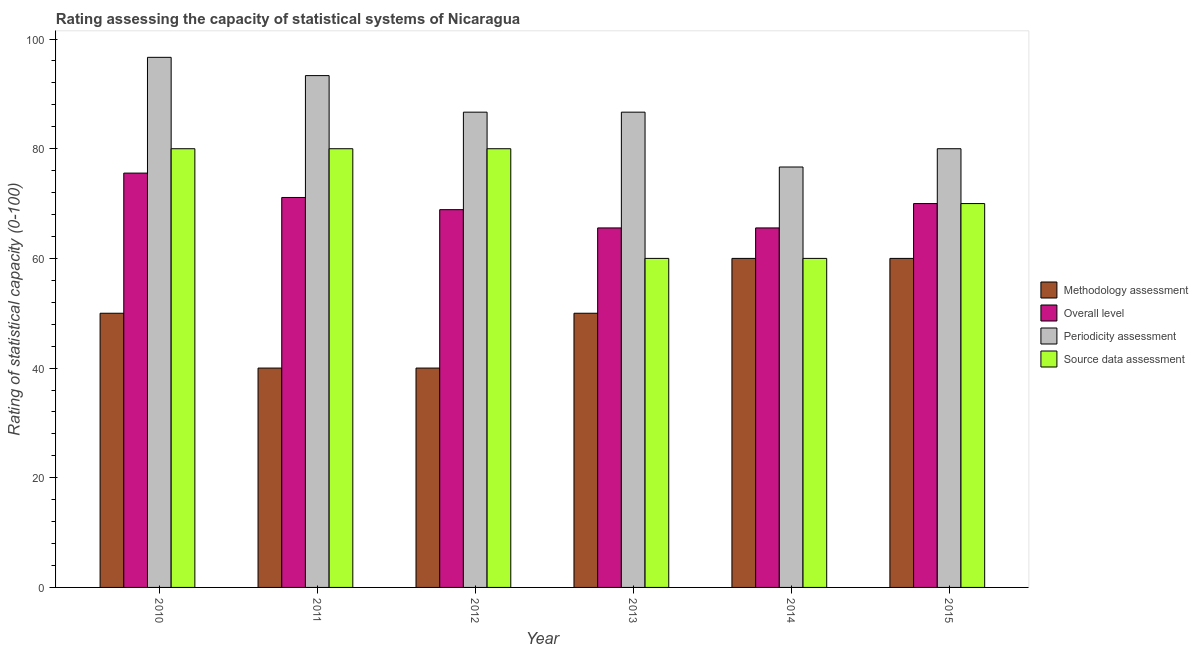Are the number of bars per tick equal to the number of legend labels?
Offer a very short reply. Yes. What is the label of the 4th group of bars from the left?
Provide a succinct answer. 2013. What is the methodology assessment rating in 2011?
Ensure brevity in your answer.  40. Across all years, what is the maximum source data assessment rating?
Provide a short and direct response. 80. Across all years, what is the minimum methodology assessment rating?
Provide a short and direct response. 40. In which year was the methodology assessment rating maximum?
Your response must be concise. 2014. In which year was the source data assessment rating minimum?
Provide a short and direct response. 2013. What is the total periodicity assessment rating in the graph?
Give a very brief answer. 520. What is the difference between the periodicity assessment rating in 2014 and that in 2015?
Provide a short and direct response. -3.33. What is the difference between the overall level rating in 2013 and the methodology assessment rating in 2011?
Your response must be concise. -5.56. What is the ratio of the periodicity assessment rating in 2010 to that in 2013?
Keep it short and to the point. 1.12. Is the overall level rating in 2010 less than that in 2015?
Offer a very short reply. No. Is the difference between the methodology assessment rating in 2012 and 2015 greater than the difference between the periodicity assessment rating in 2012 and 2015?
Your answer should be compact. No. What is the difference between the highest and the lowest periodicity assessment rating?
Give a very brief answer. 20. What does the 3rd bar from the left in 2015 represents?
Keep it short and to the point. Periodicity assessment. What does the 4th bar from the right in 2011 represents?
Your answer should be compact. Methodology assessment. Is it the case that in every year, the sum of the methodology assessment rating and overall level rating is greater than the periodicity assessment rating?
Make the answer very short. Yes. How many bars are there?
Make the answer very short. 24. How many years are there in the graph?
Give a very brief answer. 6. What is the difference between two consecutive major ticks on the Y-axis?
Your answer should be compact. 20. Does the graph contain any zero values?
Keep it short and to the point. No. Does the graph contain grids?
Ensure brevity in your answer.  No. How many legend labels are there?
Provide a succinct answer. 4. What is the title of the graph?
Provide a short and direct response. Rating assessing the capacity of statistical systems of Nicaragua. What is the label or title of the Y-axis?
Provide a succinct answer. Rating of statistical capacity (0-100). What is the Rating of statistical capacity (0-100) in Overall level in 2010?
Your answer should be very brief. 75.56. What is the Rating of statistical capacity (0-100) in Periodicity assessment in 2010?
Your answer should be compact. 96.67. What is the Rating of statistical capacity (0-100) of Methodology assessment in 2011?
Provide a succinct answer. 40. What is the Rating of statistical capacity (0-100) of Overall level in 2011?
Your answer should be compact. 71.11. What is the Rating of statistical capacity (0-100) of Periodicity assessment in 2011?
Give a very brief answer. 93.33. What is the Rating of statistical capacity (0-100) of Source data assessment in 2011?
Make the answer very short. 80. What is the Rating of statistical capacity (0-100) in Overall level in 2012?
Provide a succinct answer. 68.89. What is the Rating of statistical capacity (0-100) of Periodicity assessment in 2012?
Keep it short and to the point. 86.67. What is the Rating of statistical capacity (0-100) in Source data assessment in 2012?
Offer a very short reply. 80. What is the Rating of statistical capacity (0-100) of Methodology assessment in 2013?
Your answer should be very brief. 50. What is the Rating of statistical capacity (0-100) of Overall level in 2013?
Give a very brief answer. 65.56. What is the Rating of statistical capacity (0-100) in Periodicity assessment in 2013?
Give a very brief answer. 86.67. What is the Rating of statistical capacity (0-100) of Source data assessment in 2013?
Offer a very short reply. 60. What is the Rating of statistical capacity (0-100) of Overall level in 2014?
Offer a terse response. 65.56. What is the Rating of statistical capacity (0-100) of Periodicity assessment in 2014?
Provide a short and direct response. 76.67. What is the Rating of statistical capacity (0-100) of Periodicity assessment in 2015?
Give a very brief answer. 80. Across all years, what is the maximum Rating of statistical capacity (0-100) in Methodology assessment?
Ensure brevity in your answer.  60. Across all years, what is the maximum Rating of statistical capacity (0-100) in Overall level?
Your response must be concise. 75.56. Across all years, what is the maximum Rating of statistical capacity (0-100) of Periodicity assessment?
Keep it short and to the point. 96.67. Across all years, what is the maximum Rating of statistical capacity (0-100) in Source data assessment?
Offer a terse response. 80. Across all years, what is the minimum Rating of statistical capacity (0-100) in Overall level?
Provide a succinct answer. 65.56. Across all years, what is the minimum Rating of statistical capacity (0-100) in Periodicity assessment?
Offer a very short reply. 76.67. Across all years, what is the minimum Rating of statistical capacity (0-100) in Source data assessment?
Ensure brevity in your answer.  60. What is the total Rating of statistical capacity (0-100) in Methodology assessment in the graph?
Offer a very short reply. 300. What is the total Rating of statistical capacity (0-100) in Overall level in the graph?
Your answer should be compact. 416.67. What is the total Rating of statistical capacity (0-100) of Periodicity assessment in the graph?
Your answer should be very brief. 520. What is the total Rating of statistical capacity (0-100) in Source data assessment in the graph?
Offer a terse response. 430. What is the difference between the Rating of statistical capacity (0-100) in Methodology assessment in 2010 and that in 2011?
Offer a terse response. 10. What is the difference between the Rating of statistical capacity (0-100) of Overall level in 2010 and that in 2011?
Provide a short and direct response. 4.44. What is the difference between the Rating of statistical capacity (0-100) of Periodicity assessment in 2010 and that in 2011?
Give a very brief answer. 3.33. What is the difference between the Rating of statistical capacity (0-100) in Source data assessment in 2010 and that in 2011?
Offer a terse response. 0. What is the difference between the Rating of statistical capacity (0-100) in Overall level in 2010 and that in 2012?
Your response must be concise. 6.67. What is the difference between the Rating of statistical capacity (0-100) in Periodicity assessment in 2010 and that in 2012?
Keep it short and to the point. 10. What is the difference between the Rating of statistical capacity (0-100) of Methodology assessment in 2010 and that in 2013?
Give a very brief answer. 0. What is the difference between the Rating of statistical capacity (0-100) in Source data assessment in 2010 and that in 2013?
Offer a very short reply. 20. What is the difference between the Rating of statistical capacity (0-100) of Overall level in 2010 and that in 2015?
Keep it short and to the point. 5.56. What is the difference between the Rating of statistical capacity (0-100) in Periodicity assessment in 2010 and that in 2015?
Keep it short and to the point. 16.67. What is the difference between the Rating of statistical capacity (0-100) of Overall level in 2011 and that in 2012?
Provide a succinct answer. 2.22. What is the difference between the Rating of statistical capacity (0-100) in Periodicity assessment in 2011 and that in 2012?
Ensure brevity in your answer.  6.67. What is the difference between the Rating of statistical capacity (0-100) in Source data assessment in 2011 and that in 2012?
Provide a succinct answer. 0. What is the difference between the Rating of statistical capacity (0-100) in Methodology assessment in 2011 and that in 2013?
Your answer should be compact. -10. What is the difference between the Rating of statistical capacity (0-100) of Overall level in 2011 and that in 2013?
Keep it short and to the point. 5.56. What is the difference between the Rating of statistical capacity (0-100) of Periodicity assessment in 2011 and that in 2013?
Keep it short and to the point. 6.67. What is the difference between the Rating of statistical capacity (0-100) of Source data assessment in 2011 and that in 2013?
Ensure brevity in your answer.  20. What is the difference between the Rating of statistical capacity (0-100) in Methodology assessment in 2011 and that in 2014?
Your answer should be compact. -20. What is the difference between the Rating of statistical capacity (0-100) of Overall level in 2011 and that in 2014?
Your answer should be compact. 5.56. What is the difference between the Rating of statistical capacity (0-100) in Periodicity assessment in 2011 and that in 2014?
Ensure brevity in your answer.  16.67. What is the difference between the Rating of statistical capacity (0-100) of Methodology assessment in 2011 and that in 2015?
Your response must be concise. -20. What is the difference between the Rating of statistical capacity (0-100) in Overall level in 2011 and that in 2015?
Keep it short and to the point. 1.11. What is the difference between the Rating of statistical capacity (0-100) in Periodicity assessment in 2011 and that in 2015?
Your answer should be compact. 13.33. What is the difference between the Rating of statistical capacity (0-100) in Source data assessment in 2011 and that in 2015?
Provide a short and direct response. 10. What is the difference between the Rating of statistical capacity (0-100) in Source data assessment in 2012 and that in 2013?
Your response must be concise. 20. What is the difference between the Rating of statistical capacity (0-100) in Methodology assessment in 2012 and that in 2014?
Give a very brief answer. -20. What is the difference between the Rating of statistical capacity (0-100) of Overall level in 2012 and that in 2014?
Make the answer very short. 3.33. What is the difference between the Rating of statistical capacity (0-100) of Overall level in 2012 and that in 2015?
Your response must be concise. -1.11. What is the difference between the Rating of statistical capacity (0-100) in Periodicity assessment in 2012 and that in 2015?
Your answer should be compact. 6.67. What is the difference between the Rating of statistical capacity (0-100) in Source data assessment in 2012 and that in 2015?
Ensure brevity in your answer.  10. What is the difference between the Rating of statistical capacity (0-100) of Methodology assessment in 2013 and that in 2014?
Offer a terse response. -10. What is the difference between the Rating of statistical capacity (0-100) of Source data assessment in 2013 and that in 2014?
Your answer should be very brief. 0. What is the difference between the Rating of statistical capacity (0-100) in Methodology assessment in 2013 and that in 2015?
Offer a terse response. -10. What is the difference between the Rating of statistical capacity (0-100) of Overall level in 2013 and that in 2015?
Make the answer very short. -4.44. What is the difference between the Rating of statistical capacity (0-100) of Periodicity assessment in 2013 and that in 2015?
Keep it short and to the point. 6.67. What is the difference between the Rating of statistical capacity (0-100) of Methodology assessment in 2014 and that in 2015?
Keep it short and to the point. 0. What is the difference between the Rating of statistical capacity (0-100) in Overall level in 2014 and that in 2015?
Your answer should be very brief. -4.44. What is the difference between the Rating of statistical capacity (0-100) in Source data assessment in 2014 and that in 2015?
Keep it short and to the point. -10. What is the difference between the Rating of statistical capacity (0-100) of Methodology assessment in 2010 and the Rating of statistical capacity (0-100) of Overall level in 2011?
Make the answer very short. -21.11. What is the difference between the Rating of statistical capacity (0-100) of Methodology assessment in 2010 and the Rating of statistical capacity (0-100) of Periodicity assessment in 2011?
Offer a terse response. -43.33. What is the difference between the Rating of statistical capacity (0-100) of Methodology assessment in 2010 and the Rating of statistical capacity (0-100) of Source data assessment in 2011?
Your response must be concise. -30. What is the difference between the Rating of statistical capacity (0-100) of Overall level in 2010 and the Rating of statistical capacity (0-100) of Periodicity assessment in 2011?
Offer a very short reply. -17.78. What is the difference between the Rating of statistical capacity (0-100) in Overall level in 2010 and the Rating of statistical capacity (0-100) in Source data assessment in 2011?
Give a very brief answer. -4.44. What is the difference between the Rating of statistical capacity (0-100) in Periodicity assessment in 2010 and the Rating of statistical capacity (0-100) in Source data assessment in 2011?
Your response must be concise. 16.67. What is the difference between the Rating of statistical capacity (0-100) in Methodology assessment in 2010 and the Rating of statistical capacity (0-100) in Overall level in 2012?
Give a very brief answer. -18.89. What is the difference between the Rating of statistical capacity (0-100) in Methodology assessment in 2010 and the Rating of statistical capacity (0-100) in Periodicity assessment in 2012?
Keep it short and to the point. -36.67. What is the difference between the Rating of statistical capacity (0-100) in Overall level in 2010 and the Rating of statistical capacity (0-100) in Periodicity assessment in 2012?
Keep it short and to the point. -11.11. What is the difference between the Rating of statistical capacity (0-100) of Overall level in 2010 and the Rating of statistical capacity (0-100) of Source data assessment in 2012?
Keep it short and to the point. -4.44. What is the difference between the Rating of statistical capacity (0-100) in Periodicity assessment in 2010 and the Rating of statistical capacity (0-100) in Source data assessment in 2012?
Offer a terse response. 16.67. What is the difference between the Rating of statistical capacity (0-100) of Methodology assessment in 2010 and the Rating of statistical capacity (0-100) of Overall level in 2013?
Ensure brevity in your answer.  -15.56. What is the difference between the Rating of statistical capacity (0-100) in Methodology assessment in 2010 and the Rating of statistical capacity (0-100) in Periodicity assessment in 2013?
Provide a short and direct response. -36.67. What is the difference between the Rating of statistical capacity (0-100) in Overall level in 2010 and the Rating of statistical capacity (0-100) in Periodicity assessment in 2013?
Make the answer very short. -11.11. What is the difference between the Rating of statistical capacity (0-100) of Overall level in 2010 and the Rating of statistical capacity (0-100) of Source data assessment in 2013?
Provide a short and direct response. 15.56. What is the difference between the Rating of statistical capacity (0-100) of Periodicity assessment in 2010 and the Rating of statistical capacity (0-100) of Source data assessment in 2013?
Offer a very short reply. 36.67. What is the difference between the Rating of statistical capacity (0-100) of Methodology assessment in 2010 and the Rating of statistical capacity (0-100) of Overall level in 2014?
Your answer should be compact. -15.56. What is the difference between the Rating of statistical capacity (0-100) of Methodology assessment in 2010 and the Rating of statistical capacity (0-100) of Periodicity assessment in 2014?
Provide a succinct answer. -26.67. What is the difference between the Rating of statistical capacity (0-100) of Methodology assessment in 2010 and the Rating of statistical capacity (0-100) of Source data assessment in 2014?
Keep it short and to the point. -10. What is the difference between the Rating of statistical capacity (0-100) of Overall level in 2010 and the Rating of statistical capacity (0-100) of Periodicity assessment in 2014?
Offer a very short reply. -1.11. What is the difference between the Rating of statistical capacity (0-100) of Overall level in 2010 and the Rating of statistical capacity (0-100) of Source data assessment in 2014?
Your answer should be very brief. 15.56. What is the difference between the Rating of statistical capacity (0-100) in Periodicity assessment in 2010 and the Rating of statistical capacity (0-100) in Source data assessment in 2014?
Make the answer very short. 36.67. What is the difference between the Rating of statistical capacity (0-100) of Methodology assessment in 2010 and the Rating of statistical capacity (0-100) of Overall level in 2015?
Your answer should be compact. -20. What is the difference between the Rating of statistical capacity (0-100) of Methodology assessment in 2010 and the Rating of statistical capacity (0-100) of Source data assessment in 2015?
Ensure brevity in your answer.  -20. What is the difference between the Rating of statistical capacity (0-100) of Overall level in 2010 and the Rating of statistical capacity (0-100) of Periodicity assessment in 2015?
Your answer should be compact. -4.44. What is the difference between the Rating of statistical capacity (0-100) of Overall level in 2010 and the Rating of statistical capacity (0-100) of Source data assessment in 2015?
Your response must be concise. 5.56. What is the difference between the Rating of statistical capacity (0-100) of Periodicity assessment in 2010 and the Rating of statistical capacity (0-100) of Source data assessment in 2015?
Keep it short and to the point. 26.67. What is the difference between the Rating of statistical capacity (0-100) in Methodology assessment in 2011 and the Rating of statistical capacity (0-100) in Overall level in 2012?
Make the answer very short. -28.89. What is the difference between the Rating of statistical capacity (0-100) in Methodology assessment in 2011 and the Rating of statistical capacity (0-100) in Periodicity assessment in 2012?
Your answer should be compact. -46.67. What is the difference between the Rating of statistical capacity (0-100) in Methodology assessment in 2011 and the Rating of statistical capacity (0-100) in Source data assessment in 2012?
Offer a very short reply. -40. What is the difference between the Rating of statistical capacity (0-100) in Overall level in 2011 and the Rating of statistical capacity (0-100) in Periodicity assessment in 2012?
Offer a terse response. -15.56. What is the difference between the Rating of statistical capacity (0-100) of Overall level in 2011 and the Rating of statistical capacity (0-100) of Source data assessment in 2012?
Provide a succinct answer. -8.89. What is the difference between the Rating of statistical capacity (0-100) of Periodicity assessment in 2011 and the Rating of statistical capacity (0-100) of Source data assessment in 2012?
Provide a succinct answer. 13.33. What is the difference between the Rating of statistical capacity (0-100) in Methodology assessment in 2011 and the Rating of statistical capacity (0-100) in Overall level in 2013?
Your answer should be very brief. -25.56. What is the difference between the Rating of statistical capacity (0-100) of Methodology assessment in 2011 and the Rating of statistical capacity (0-100) of Periodicity assessment in 2013?
Your answer should be very brief. -46.67. What is the difference between the Rating of statistical capacity (0-100) in Overall level in 2011 and the Rating of statistical capacity (0-100) in Periodicity assessment in 2013?
Offer a terse response. -15.56. What is the difference between the Rating of statistical capacity (0-100) of Overall level in 2011 and the Rating of statistical capacity (0-100) of Source data assessment in 2013?
Provide a short and direct response. 11.11. What is the difference between the Rating of statistical capacity (0-100) of Periodicity assessment in 2011 and the Rating of statistical capacity (0-100) of Source data assessment in 2013?
Ensure brevity in your answer.  33.33. What is the difference between the Rating of statistical capacity (0-100) of Methodology assessment in 2011 and the Rating of statistical capacity (0-100) of Overall level in 2014?
Your answer should be very brief. -25.56. What is the difference between the Rating of statistical capacity (0-100) in Methodology assessment in 2011 and the Rating of statistical capacity (0-100) in Periodicity assessment in 2014?
Ensure brevity in your answer.  -36.67. What is the difference between the Rating of statistical capacity (0-100) in Methodology assessment in 2011 and the Rating of statistical capacity (0-100) in Source data assessment in 2014?
Make the answer very short. -20. What is the difference between the Rating of statistical capacity (0-100) in Overall level in 2011 and the Rating of statistical capacity (0-100) in Periodicity assessment in 2014?
Give a very brief answer. -5.56. What is the difference between the Rating of statistical capacity (0-100) in Overall level in 2011 and the Rating of statistical capacity (0-100) in Source data assessment in 2014?
Provide a succinct answer. 11.11. What is the difference between the Rating of statistical capacity (0-100) in Periodicity assessment in 2011 and the Rating of statistical capacity (0-100) in Source data assessment in 2014?
Make the answer very short. 33.33. What is the difference between the Rating of statistical capacity (0-100) of Methodology assessment in 2011 and the Rating of statistical capacity (0-100) of Source data assessment in 2015?
Provide a short and direct response. -30. What is the difference between the Rating of statistical capacity (0-100) of Overall level in 2011 and the Rating of statistical capacity (0-100) of Periodicity assessment in 2015?
Make the answer very short. -8.89. What is the difference between the Rating of statistical capacity (0-100) of Overall level in 2011 and the Rating of statistical capacity (0-100) of Source data assessment in 2015?
Provide a succinct answer. 1.11. What is the difference between the Rating of statistical capacity (0-100) of Periodicity assessment in 2011 and the Rating of statistical capacity (0-100) of Source data assessment in 2015?
Give a very brief answer. 23.33. What is the difference between the Rating of statistical capacity (0-100) in Methodology assessment in 2012 and the Rating of statistical capacity (0-100) in Overall level in 2013?
Offer a very short reply. -25.56. What is the difference between the Rating of statistical capacity (0-100) of Methodology assessment in 2012 and the Rating of statistical capacity (0-100) of Periodicity assessment in 2013?
Provide a succinct answer. -46.67. What is the difference between the Rating of statistical capacity (0-100) of Methodology assessment in 2012 and the Rating of statistical capacity (0-100) of Source data assessment in 2013?
Your answer should be compact. -20. What is the difference between the Rating of statistical capacity (0-100) of Overall level in 2012 and the Rating of statistical capacity (0-100) of Periodicity assessment in 2013?
Your answer should be compact. -17.78. What is the difference between the Rating of statistical capacity (0-100) in Overall level in 2012 and the Rating of statistical capacity (0-100) in Source data assessment in 2013?
Your response must be concise. 8.89. What is the difference between the Rating of statistical capacity (0-100) of Periodicity assessment in 2012 and the Rating of statistical capacity (0-100) of Source data assessment in 2013?
Give a very brief answer. 26.67. What is the difference between the Rating of statistical capacity (0-100) of Methodology assessment in 2012 and the Rating of statistical capacity (0-100) of Overall level in 2014?
Provide a succinct answer. -25.56. What is the difference between the Rating of statistical capacity (0-100) of Methodology assessment in 2012 and the Rating of statistical capacity (0-100) of Periodicity assessment in 2014?
Keep it short and to the point. -36.67. What is the difference between the Rating of statistical capacity (0-100) of Methodology assessment in 2012 and the Rating of statistical capacity (0-100) of Source data assessment in 2014?
Give a very brief answer. -20. What is the difference between the Rating of statistical capacity (0-100) of Overall level in 2012 and the Rating of statistical capacity (0-100) of Periodicity assessment in 2014?
Provide a succinct answer. -7.78. What is the difference between the Rating of statistical capacity (0-100) in Overall level in 2012 and the Rating of statistical capacity (0-100) in Source data assessment in 2014?
Provide a succinct answer. 8.89. What is the difference between the Rating of statistical capacity (0-100) in Periodicity assessment in 2012 and the Rating of statistical capacity (0-100) in Source data assessment in 2014?
Your response must be concise. 26.67. What is the difference between the Rating of statistical capacity (0-100) of Overall level in 2012 and the Rating of statistical capacity (0-100) of Periodicity assessment in 2015?
Your answer should be very brief. -11.11. What is the difference between the Rating of statistical capacity (0-100) of Overall level in 2012 and the Rating of statistical capacity (0-100) of Source data assessment in 2015?
Ensure brevity in your answer.  -1.11. What is the difference between the Rating of statistical capacity (0-100) of Periodicity assessment in 2012 and the Rating of statistical capacity (0-100) of Source data assessment in 2015?
Your response must be concise. 16.67. What is the difference between the Rating of statistical capacity (0-100) of Methodology assessment in 2013 and the Rating of statistical capacity (0-100) of Overall level in 2014?
Your answer should be compact. -15.56. What is the difference between the Rating of statistical capacity (0-100) of Methodology assessment in 2013 and the Rating of statistical capacity (0-100) of Periodicity assessment in 2014?
Keep it short and to the point. -26.67. What is the difference between the Rating of statistical capacity (0-100) in Methodology assessment in 2013 and the Rating of statistical capacity (0-100) in Source data assessment in 2014?
Make the answer very short. -10. What is the difference between the Rating of statistical capacity (0-100) of Overall level in 2013 and the Rating of statistical capacity (0-100) of Periodicity assessment in 2014?
Give a very brief answer. -11.11. What is the difference between the Rating of statistical capacity (0-100) in Overall level in 2013 and the Rating of statistical capacity (0-100) in Source data assessment in 2014?
Keep it short and to the point. 5.56. What is the difference between the Rating of statistical capacity (0-100) in Periodicity assessment in 2013 and the Rating of statistical capacity (0-100) in Source data assessment in 2014?
Make the answer very short. 26.67. What is the difference between the Rating of statistical capacity (0-100) in Overall level in 2013 and the Rating of statistical capacity (0-100) in Periodicity assessment in 2015?
Keep it short and to the point. -14.44. What is the difference between the Rating of statistical capacity (0-100) of Overall level in 2013 and the Rating of statistical capacity (0-100) of Source data assessment in 2015?
Make the answer very short. -4.44. What is the difference between the Rating of statistical capacity (0-100) in Periodicity assessment in 2013 and the Rating of statistical capacity (0-100) in Source data assessment in 2015?
Your answer should be very brief. 16.67. What is the difference between the Rating of statistical capacity (0-100) of Methodology assessment in 2014 and the Rating of statistical capacity (0-100) of Overall level in 2015?
Provide a short and direct response. -10. What is the difference between the Rating of statistical capacity (0-100) in Methodology assessment in 2014 and the Rating of statistical capacity (0-100) in Source data assessment in 2015?
Offer a very short reply. -10. What is the difference between the Rating of statistical capacity (0-100) of Overall level in 2014 and the Rating of statistical capacity (0-100) of Periodicity assessment in 2015?
Offer a terse response. -14.44. What is the difference between the Rating of statistical capacity (0-100) in Overall level in 2014 and the Rating of statistical capacity (0-100) in Source data assessment in 2015?
Your answer should be very brief. -4.44. What is the average Rating of statistical capacity (0-100) of Methodology assessment per year?
Provide a succinct answer. 50. What is the average Rating of statistical capacity (0-100) of Overall level per year?
Offer a very short reply. 69.44. What is the average Rating of statistical capacity (0-100) in Periodicity assessment per year?
Make the answer very short. 86.67. What is the average Rating of statistical capacity (0-100) in Source data assessment per year?
Ensure brevity in your answer.  71.67. In the year 2010, what is the difference between the Rating of statistical capacity (0-100) in Methodology assessment and Rating of statistical capacity (0-100) in Overall level?
Offer a terse response. -25.56. In the year 2010, what is the difference between the Rating of statistical capacity (0-100) of Methodology assessment and Rating of statistical capacity (0-100) of Periodicity assessment?
Offer a terse response. -46.67. In the year 2010, what is the difference between the Rating of statistical capacity (0-100) of Methodology assessment and Rating of statistical capacity (0-100) of Source data assessment?
Your answer should be very brief. -30. In the year 2010, what is the difference between the Rating of statistical capacity (0-100) of Overall level and Rating of statistical capacity (0-100) of Periodicity assessment?
Give a very brief answer. -21.11. In the year 2010, what is the difference between the Rating of statistical capacity (0-100) in Overall level and Rating of statistical capacity (0-100) in Source data assessment?
Offer a terse response. -4.44. In the year 2010, what is the difference between the Rating of statistical capacity (0-100) in Periodicity assessment and Rating of statistical capacity (0-100) in Source data assessment?
Make the answer very short. 16.67. In the year 2011, what is the difference between the Rating of statistical capacity (0-100) of Methodology assessment and Rating of statistical capacity (0-100) of Overall level?
Offer a terse response. -31.11. In the year 2011, what is the difference between the Rating of statistical capacity (0-100) of Methodology assessment and Rating of statistical capacity (0-100) of Periodicity assessment?
Offer a terse response. -53.33. In the year 2011, what is the difference between the Rating of statistical capacity (0-100) of Overall level and Rating of statistical capacity (0-100) of Periodicity assessment?
Keep it short and to the point. -22.22. In the year 2011, what is the difference between the Rating of statistical capacity (0-100) of Overall level and Rating of statistical capacity (0-100) of Source data assessment?
Provide a succinct answer. -8.89. In the year 2011, what is the difference between the Rating of statistical capacity (0-100) in Periodicity assessment and Rating of statistical capacity (0-100) in Source data assessment?
Give a very brief answer. 13.33. In the year 2012, what is the difference between the Rating of statistical capacity (0-100) in Methodology assessment and Rating of statistical capacity (0-100) in Overall level?
Ensure brevity in your answer.  -28.89. In the year 2012, what is the difference between the Rating of statistical capacity (0-100) of Methodology assessment and Rating of statistical capacity (0-100) of Periodicity assessment?
Ensure brevity in your answer.  -46.67. In the year 2012, what is the difference between the Rating of statistical capacity (0-100) of Overall level and Rating of statistical capacity (0-100) of Periodicity assessment?
Provide a succinct answer. -17.78. In the year 2012, what is the difference between the Rating of statistical capacity (0-100) of Overall level and Rating of statistical capacity (0-100) of Source data assessment?
Provide a short and direct response. -11.11. In the year 2013, what is the difference between the Rating of statistical capacity (0-100) in Methodology assessment and Rating of statistical capacity (0-100) in Overall level?
Make the answer very short. -15.56. In the year 2013, what is the difference between the Rating of statistical capacity (0-100) of Methodology assessment and Rating of statistical capacity (0-100) of Periodicity assessment?
Your response must be concise. -36.67. In the year 2013, what is the difference between the Rating of statistical capacity (0-100) of Overall level and Rating of statistical capacity (0-100) of Periodicity assessment?
Keep it short and to the point. -21.11. In the year 2013, what is the difference between the Rating of statistical capacity (0-100) of Overall level and Rating of statistical capacity (0-100) of Source data assessment?
Make the answer very short. 5.56. In the year 2013, what is the difference between the Rating of statistical capacity (0-100) in Periodicity assessment and Rating of statistical capacity (0-100) in Source data assessment?
Your answer should be very brief. 26.67. In the year 2014, what is the difference between the Rating of statistical capacity (0-100) of Methodology assessment and Rating of statistical capacity (0-100) of Overall level?
Ensure brevity in your answer.  -5.56. In the year 2014, what is the difference between the Rating of statistical capacity (0-100) of Methodology assessment and Rating of statistical capacity (0-100) of Periodicity assessment?
Make the answer very short. -16.67. In the year 2014, what is the difference between the Rating of statistical capacity (0-100) in Overall level and Rating of statistical capacity (0-100) in Periodicity assessment?
Your answer should be very brief. -11.11. In the year 2014, what is the difference between the Rating of statistical capacity (0-100) in Overall level and Rating of statistical capacity (0-100) in Source data assessment?
Ensure brevity in your answer.  5.56. In the year 2014, what is the difference between the Rating of statistical capacity (0-100) of Periodicity assessment and Rating of statistical capacity (0-100) of Source data assessment?
Offer a terse response. 16.67. In the year 2015, what is the difference between the Rating of statistical capacity (0-100) of Methodology assessment and Rating of statistical capacity (0-100) of Overall level?
Ensure brevity in your answer.  -10. In the year 2015, what is the difference between the Rating of statistical capacity (0-100) of Methodology assessment and Rating of statistical capacity (0-100) of Periodicity assessment?
Your response must be concise. -20. In the year 2015, what is the difference between the Rating of statistical capacity (0-100) of Overall level and Rating of statistical capacity (0-100) of Periodicity assessment?
Give a very brief answer. -10. In the year 2015, what is the difference between the Rating of statistical capacity (0-100) in Periodicity assessment and Rating of statistical capacity (0-100) in Source data assessment?
Offer a terse response. 10. What is the ratio of the Rating of statistical capacity (0-100) in Periodicity assessment in 2010 to that in 2011?
Keep it short and to the point. 1.04. What is the ratio of the Rating of statistical capacity (0-100) in Overall level in 2010 to that in 2012?
Give a very brief answer. 1.1. What is the ratio of the Rating of statistical capacity (0-100) in Periodicity assessment in 2010 to that in 2012?
Make the answer very short. 1.12. What is the ratio of the Rating of statistical capacity (0-100) in Source data assessment in 2010 to that in 2012?
Keep it short and to the point. 1. What is the ratio of the Rating of statistical capacity (0-100) of Overall level in 2010 to that in 2013?
Your answer should be compact. 1.15. What is the ratio of the Rating of statistical capacity (0-100) of Periodicity assessment in 2010 to that in 2013?
Your answer should be compact. 1.12. What is the ratio of the Rating of statistical capacity (0-100) in Source data assessment in 2010 to that in 2013?
Ensure brevity in your answer.  1.33. What is the ratio of the Rating of statistical capacity (0-100) in Methodology assessment in 2010 to that in 2014?
Ensure brevity in your answer.  0.83. What is the ratio of the Rating of statistical capacity (0-100) in Overall level in 2010 to that in 2014?
Make the answer very short. 1.15. What is the ratio of the Rating of statistical capacity (0-100) in Periodicity assessment in 2010 to that in 2014?
Make the answer very short. 1.26. What is the ratio of the Rating of statistical capacity (0-100) in Methodology assessment in 2010 to that in 2015?
Provide a succinct answer. 0.83. What is the ratio of the Rating of statistical capacity (0-100) of Overall level in 2010 to that in 2015?
Offer a very short reply. 1.08. What is the ratio of the Rating of statistical capacity (0-100) in Periodicity assessment in 2010 to that in 2015?
Ensure brevity in your answer.  1.21. What is the ratio of the Rating of statistical capacity (0-100) of Source data assessment in 2010 to that in 2015?
Keep it short and to the point. 1.14. What is the ratio of the Rating of statistical capacity (0-100) in Overall level in 2011 to that in 2012?
Your response must be concise. 1.03. What is the ratio of the Rating of statistical capacity (0-100) of Periodicity assessment in 2011 to that in 2012?
Provide a short and direct response. 1.08. What is the ratio of the Rating of statistical capacity (0-100) of Overall level in 2011 to that in 2013?
Offer a terse response. 1.08. What is the ratio of the Rating of statistical capacity (0-100) in Periodicity assessment in 2011 to that in 2013?
Give a very brief answer. 1.08. What is the ratio of the Rating of statistical capacity (0-100) in Source data assessment in 2011 to that in 2013?
Your answer should be compact. 1.33. What is the ratio of the Rating of statistical capacity (0-100) in Methodology assessment in 2011 to that in 2014?
Provide a short and direct response. 0.67. What is the ratio of the Rating of statistical capacity (0-100) in Overall level in 2011 to that in 2014?
Provide a succinct answer. 1.08. What is the ratio of the Rating of statistical capacity (0-100) of Periodicity assessment in 2011 to that in 2014?
Offer a terse response. 1.22. What is the ratio of the Rating of statistical capacity (0-100) in Source data assessment in 2011 to that in 2014?
Ensure brevity in your answer.  1.33. What is the ratio of the Rating of statistical capacity (0-100) in Methodology assessment in 2011 to that in 2015?
Your response must be concise. 0.67. What is the ratio of the Rating of statistical capacity (0-100) in Overall level in 2011 to that in 2015?
Your response must be concise. 1.02. What is the ratio of the Rating of statistical capacity (0-100) of Periodicity assessment in 2011 to that in 2015?
Give a very brief answer. 1.17. What is the ratio of the Rating of statistical capacity (0-100) in Methodology assessment in 2012 to that in 2013?
Your response must be concise. 0.8. What is the ratio of the Rating of statistical capacity (0-100) of Overall level in 2012 to that in 2013?
Give a very brief answer. 1.05. What is the ratio of the Rating of statistical capacity (0-100) in Periodicity assessment in 2012 to that in 2013?
Your answer should be very brief. 1. What is the ratio of the Rating of statistical capacity (0-100) of Methodology assessment in 2012 to that in 2014?
Your answer should be compact. 0.67. What is the ratio of the Rating of statistical capacity (0-100) of Overall level in 2012 to that in 2014?
Your answer should be very brief. 1.05. What is the ratio of the Rating of statistical capacity (0-100) of Periodicity assessment in 2012 to that in 2014?
Make the answer very short. 1.13. What is the ratio of the Rating of statistical capacity (0-100) in Methodology assessment in 2012 to that in 2015?
Your response must be concise. 0.67. What is the ratio of the Rating of statistical capacity (0-100) in Overall level in 2012 to that in 2015?
Provide a succinct answer. 0.98. What is the ratio of the Rating of statistical capacity (0-100) in Source data assessment in 2012 to that in 2015?
Your answer should be very brief. 1.14. What is the ratio of the Rating of statistical capacity (0-100) in Periodicity assessment in 2013 to that in 2014?
Give a very brief answer. 1.13. What is the ratio of the Rating of statistical capacity (0-100) of Source data assessment in 2013 to that in 2014?
Provide a short and direct response. 1. What is the ratio of the Rating of statistical capacity (0-100) of Overall level in 2013 to that in 2015?
Ensure brevity in your answer.  0.94. What is the ratio of the Rating of statistical capacity (0-100) in Overall level in 2014 to that in 2015?
Your answer should be very brief. 0.94. What is the ratio of the Rating of statistical capacity (0-100) of Periodicity assessment in 2014 to that in 2015?
Give a very brief answer. 0.96. What is the difference between the highest and the second highest Rating of statistical capacity (0-100) in Methodology assessment?
Offer a terse response. 0. What is the difference between the highest and the second highest Rating of statistical capacity (0-100) of Overall level?
Keep it short and to the point. 4.44. What is the difference between the highest and the second highest Rating of statistical capacity (0-100) in Source data assessment?
Provide a short and direct response. 0. What is the difference between the highest and the lowest Rating of statistical capacity (0-100) of Periodicity assessment?
Give a very brief answer. 20. What is the difference between the highest and the lowest Rating of statistical capacity (0-100) of Source data assessment?
Offer a terse response. 20. 